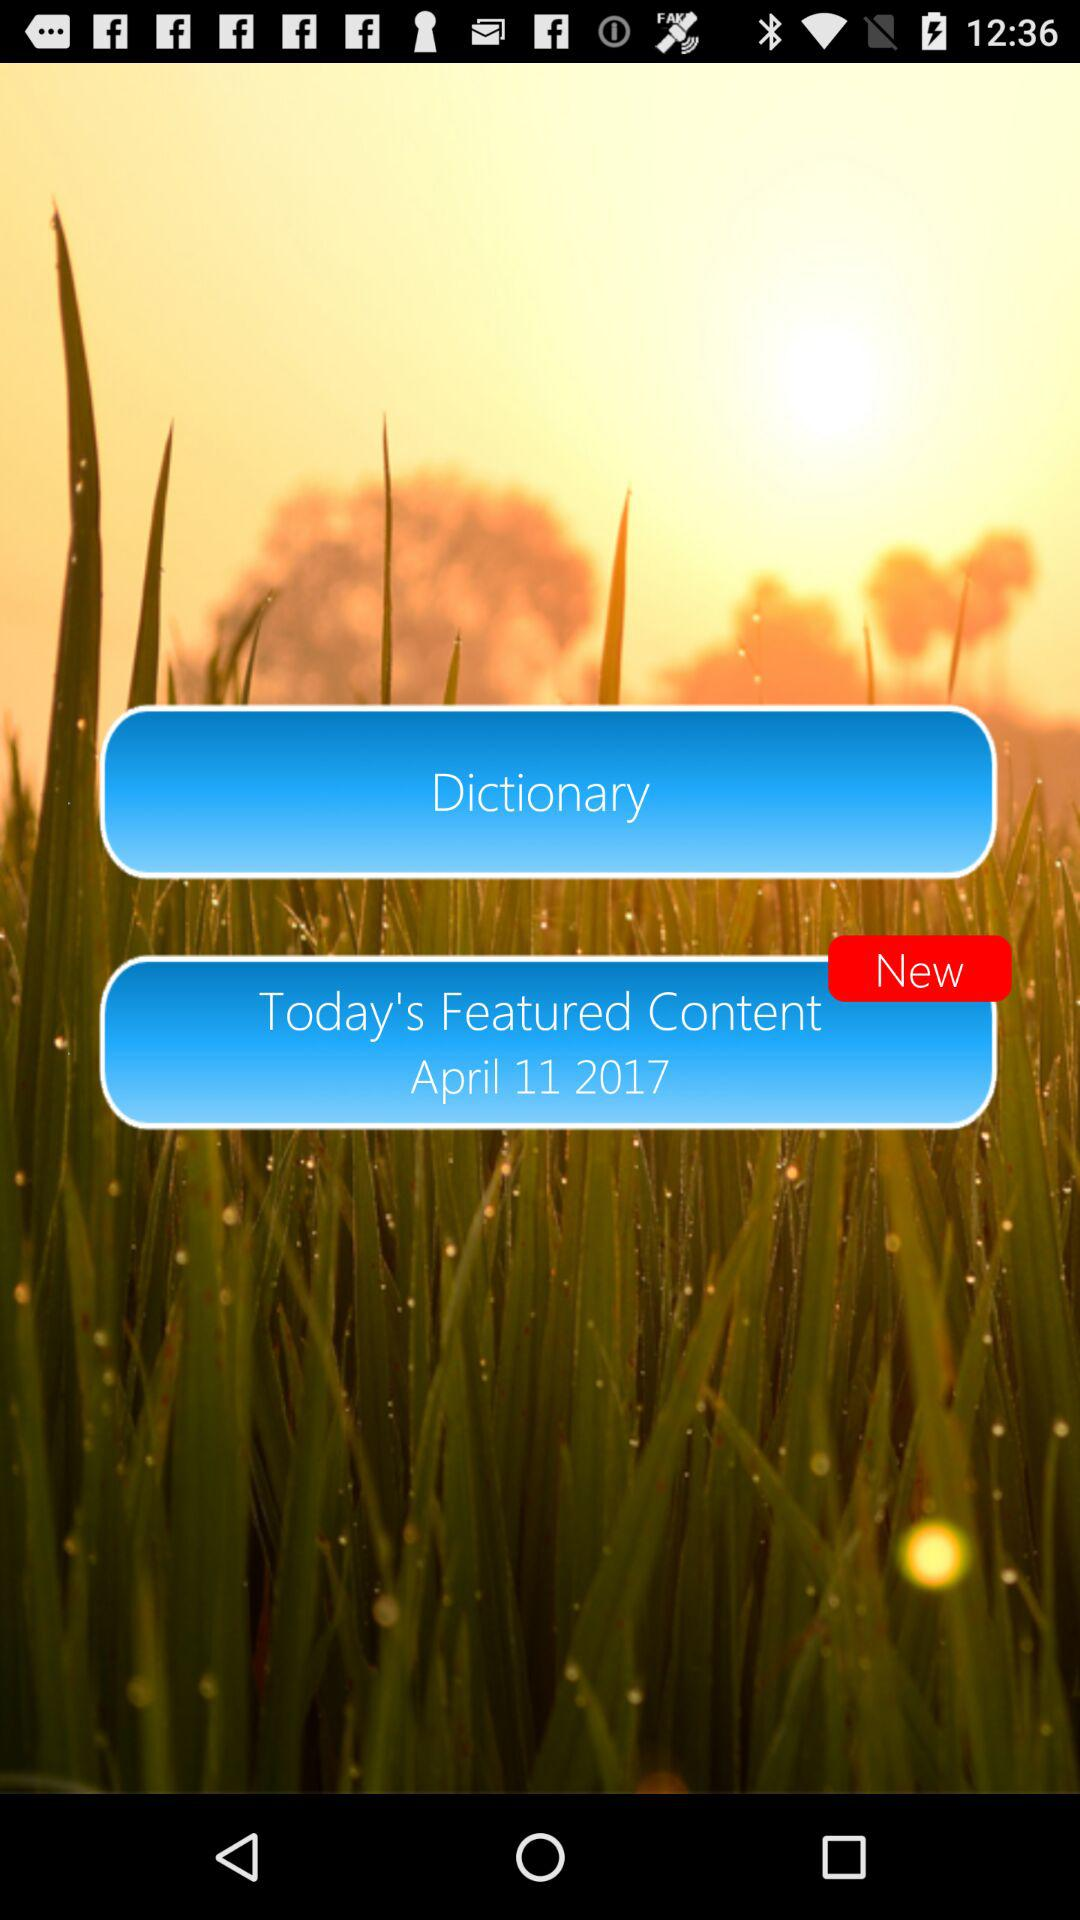What is the date on today's featured content? The date is April 11, 2017. 